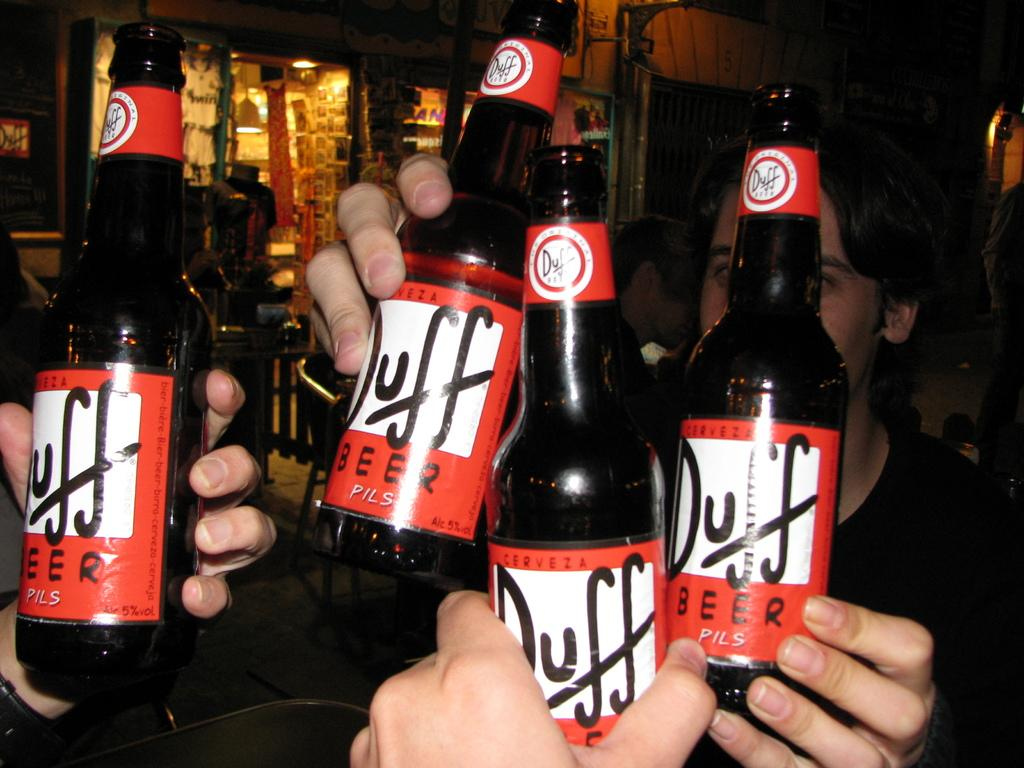<image>
Write a terse but informative summary of the picture. four people holding up bottles of duff beer 